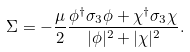Convert formula to latex. <formula><loc_0><loc_0><loc_500><loc_500>\Sigma = - \frac { \mu } { 2 } \frac { \phi ^ { \dagger } \sigma _ { 3 } \phi + \chi ^ { \dagger } \sigma _ { 3 } \chi } { | \phi | ^ { 2 } + | \chi | ^ { 2 } } .</formula> 